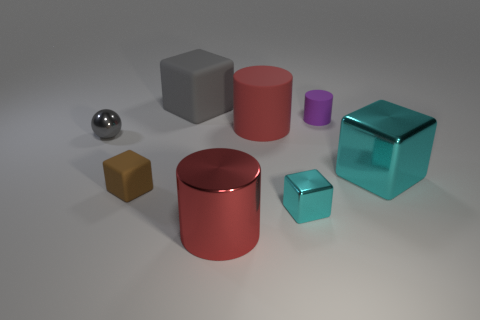Subtract 1 cylinders. How many cylinders are left? 2 Subtract all red blocks. Subtract all red spheres. How many blocks are left? 4 Add 1 large brown matte objects. How many objects exist? 9 Subtract all balls. How many objects are left? 7 Subtract 1 purple cylinders. How many objects are left? 7 Subtract all large red cylinders. Subtract all big green rubber cylinders. How many objects are left? 6 Add 6 small balls. How many small balls are left? 7 Add 3 brown objects. How many brown objects exist? 4 